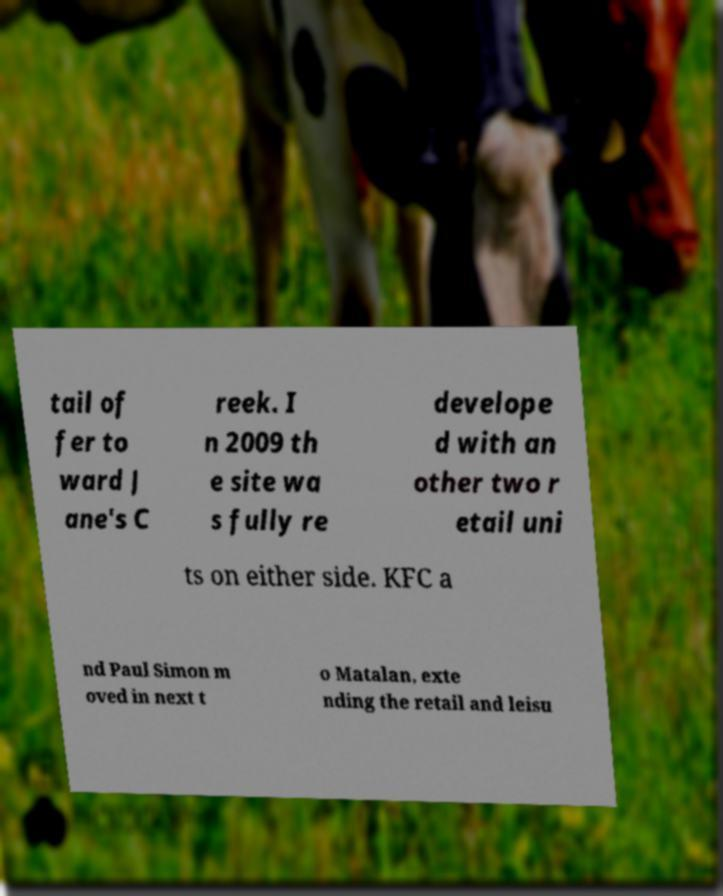What messages or text are displayed in this image? I need them in a readable, typed format. tail of fer to ward J ane's C reek. I n 2009 th e site wa s fully re develope d with an other two r etail uni ts on either side. KFC a nd Paul Simon m oved in next t o Matalan, exte nding the retail and leisu 